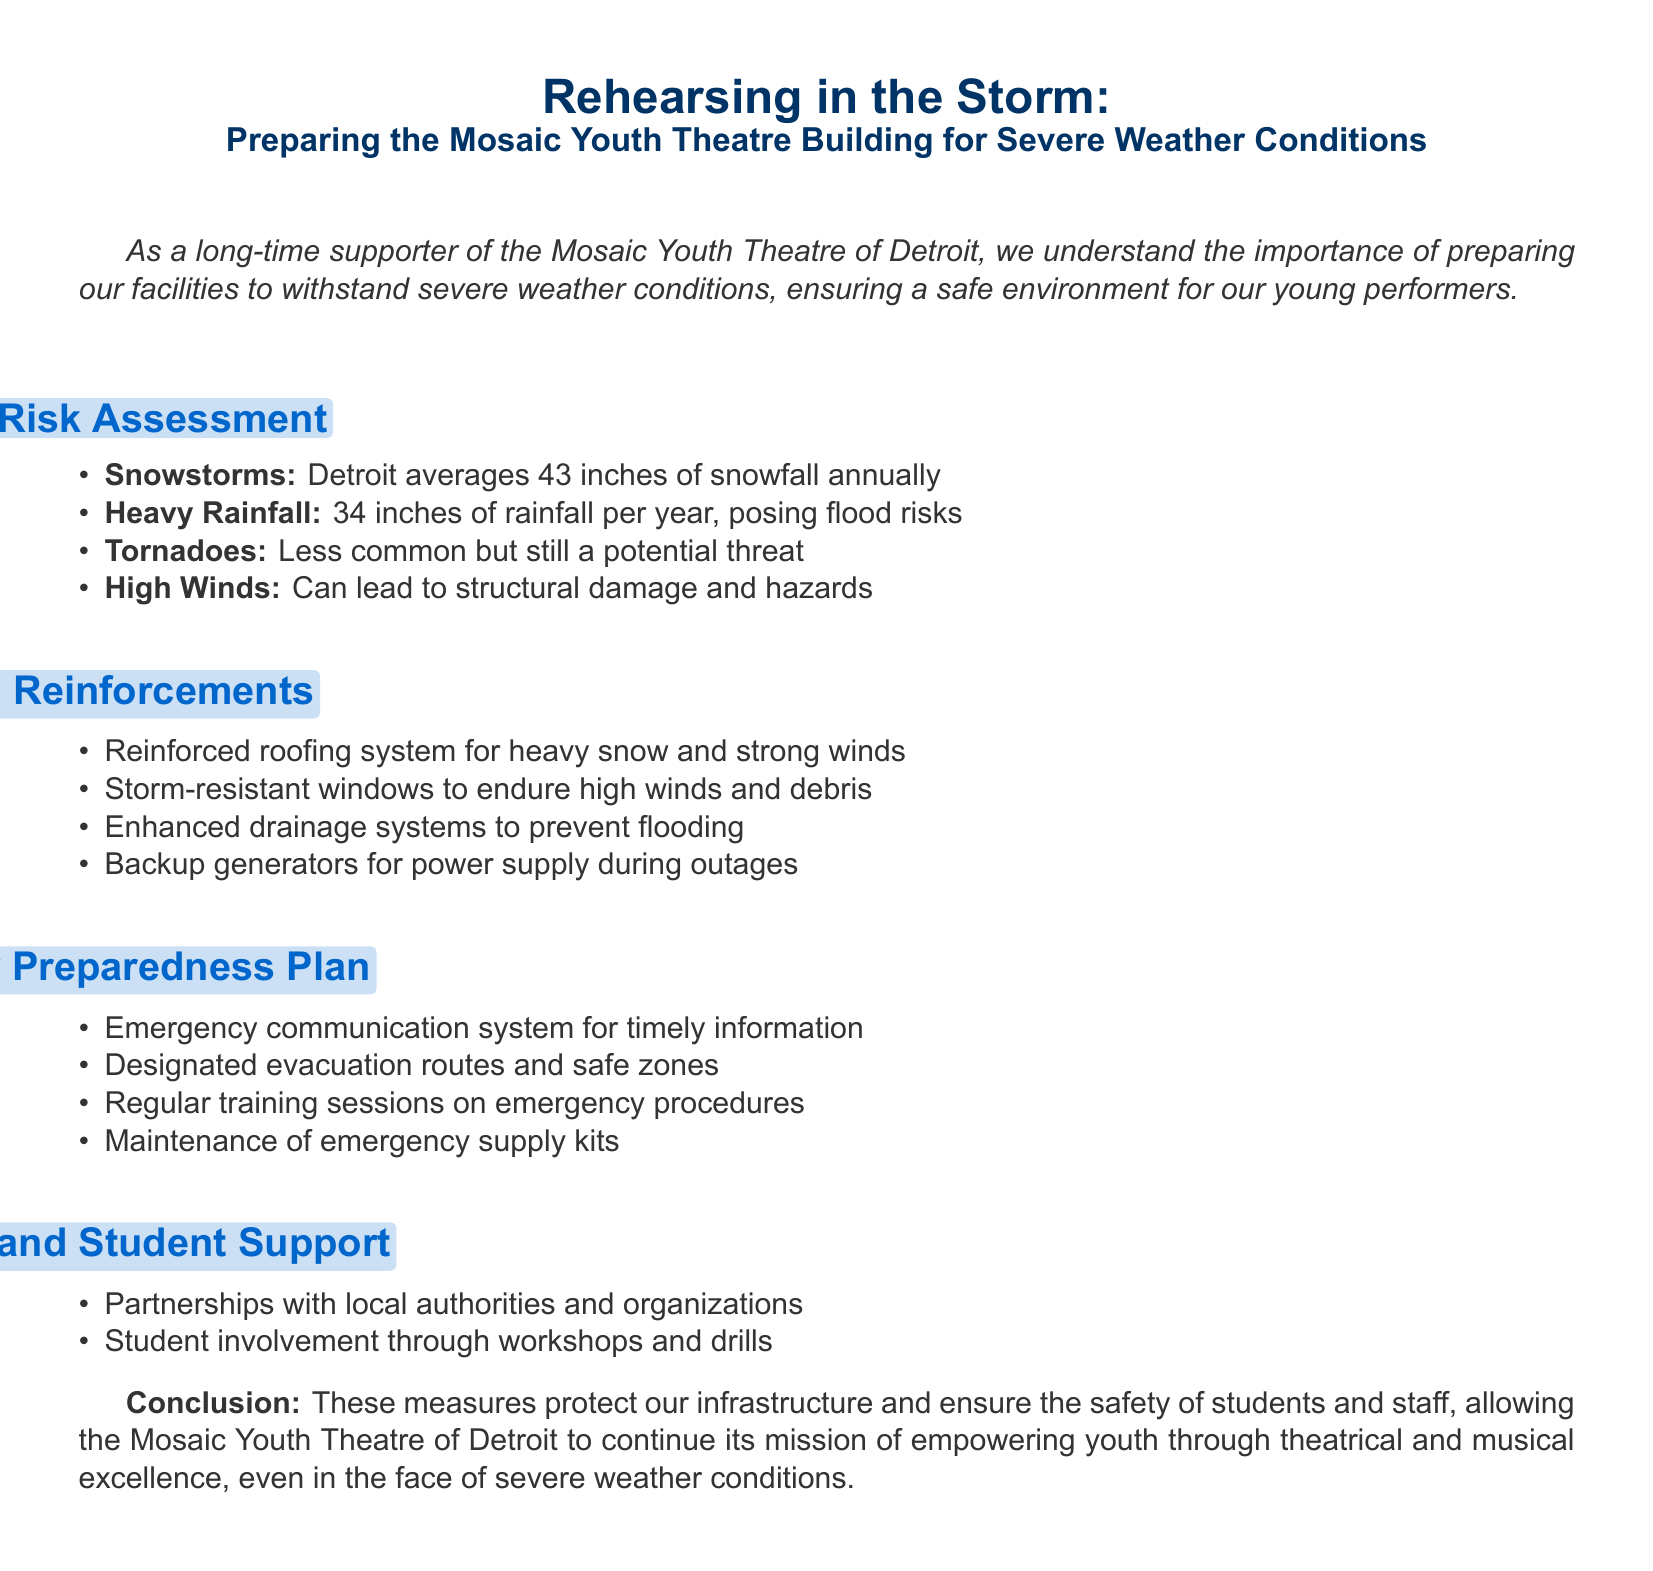what is the annual average snowfall in Detroit? The document states that Detroit averages 43 inches of snowfall annually.
Answer: 43 inches what system is used to communicate during emergencies? The document mentions an emergency communication system for timely information.
Answer: Emergency communication system what type of windows are installed to withstand severe weather? The document describes storm-resistant windows to endure high winds and debris.
Answer: Storm-resistant windows what is one of the risks associated with heavy rainfall? The document indicates flooding as a risk associated with heavy rainfall.
Answer: Flooding how many inches of rainfall does Detroit receive yearly? The document notes that Detroit receives 34 inches of rainfall per year.
Answer: 34 inches what is included in the emergency preparedness plan? The document lists regular training sessions on emergency procedures as part of the plan.
Answer: Regular training sessions what partnership is mentioned in the document? The document mentions partnerships with local authorities and organizations.
Answer: Partnerships with local authorities what is the conclusion regarding the measures taken? The document concludes that these measures ensure the safety of students and staff.
Answer: Ensure the safety of students and staff which type of weather event is less common but still mentioned? The document states that tornadoes are less common but still a potential threat.
Answer: Tornadoes 